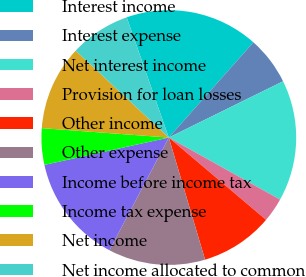Convert chart. <chart><loc_0><loc_0><loc_500><loc_500><pie_chart><fcel>Interest income<fcel>Interest expense<fcel>Net interest income<fcel>Provision for loan losses<fcel>Other income<fcel>Other expense<fcel>Income before income tax<fcel>Income tax expense<fcel>Net income<fcel>Net income allocated to common<nl><fcel>16.92%<fcel>6.16%<fcel>15.38%<fcel>3.08%<fcel>9.23%<fcel>12.31%<fcel>13.84%<fcel>4.62%<fcel>10.77%<fcel>7.69%<nl></chart> 